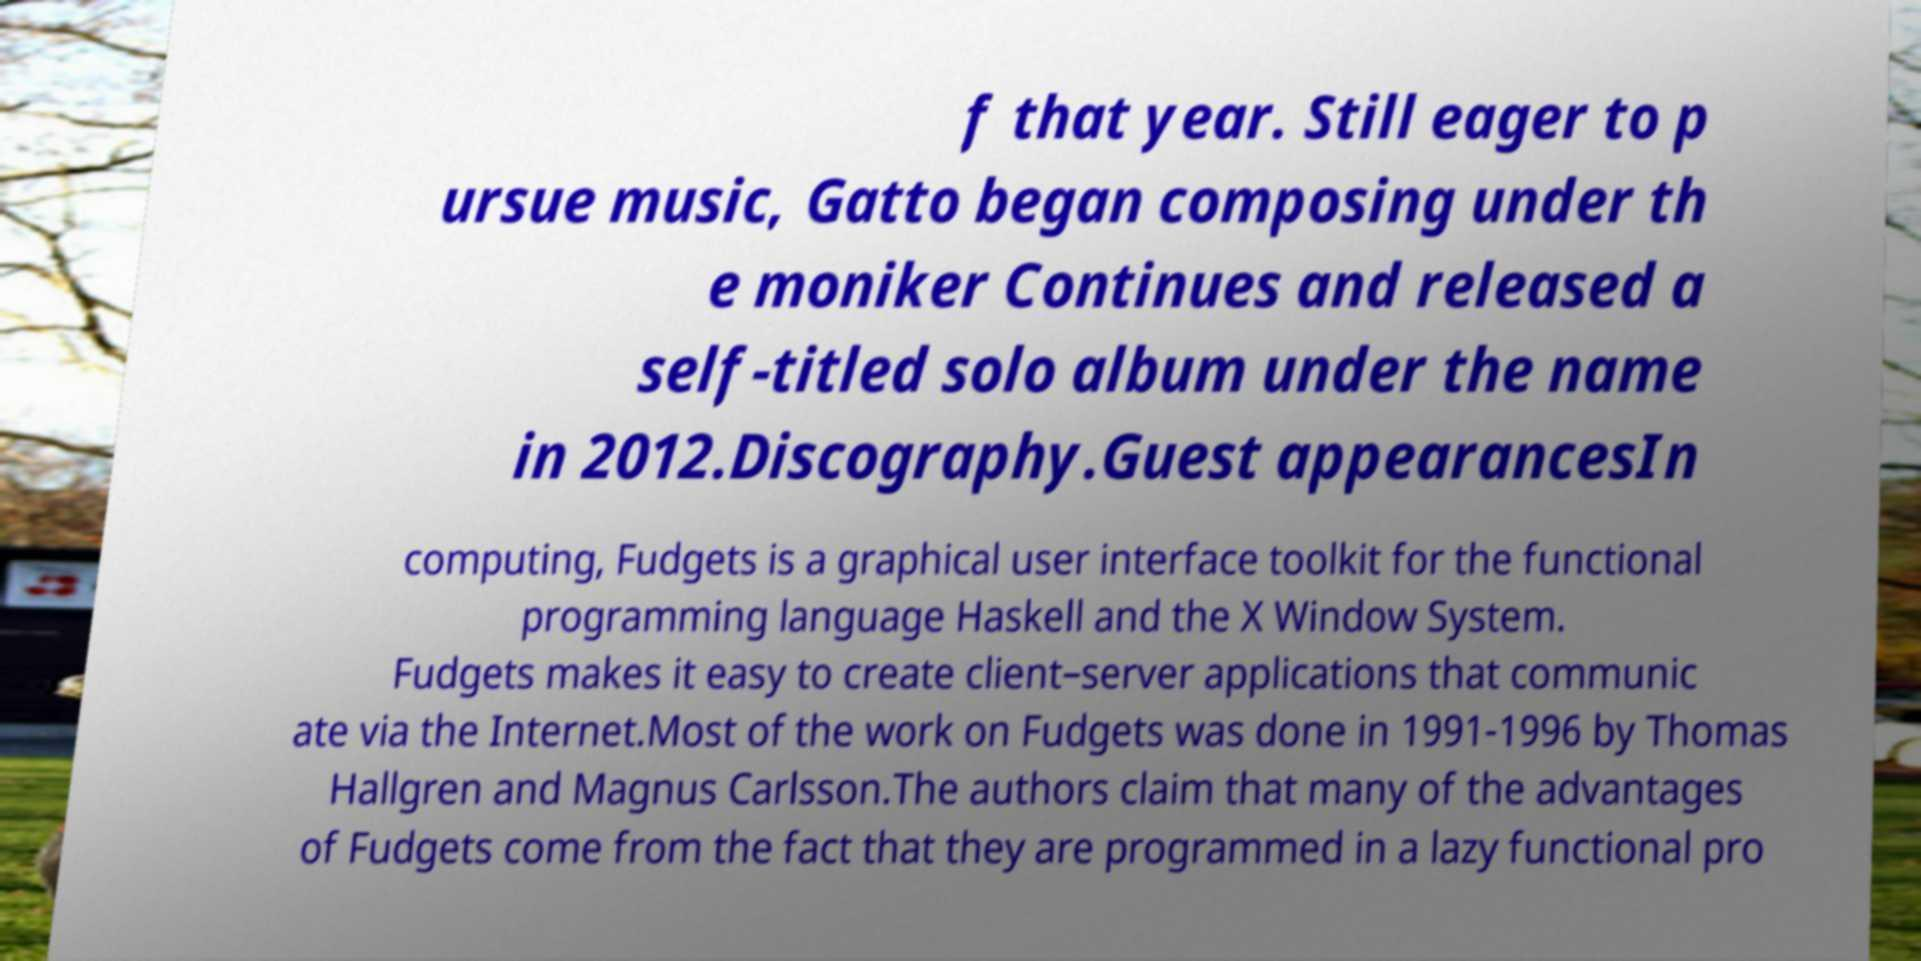What messages or text are displayed in this image? I need them in a readable, typed format. f that year. Still eager to p ursue music, Gatto began composing under th e moniker Continues and released a self-titled solo album under the name in 2012.Discography.Guest appearancesIn computing, Fudgets is a graphical user interface toolkit for the functional programming language Haskell and the X Window System. Fudgets makes it easy to create client–server applications that communic ate via the Internet.Most of the work on Fudgets was done in 1991-1996 by Thomas Hallgren and Magnus Carlsson.The authors claim that many of the advantages of Fudgets come from the fact that they are programmed in a lazy functional pro 